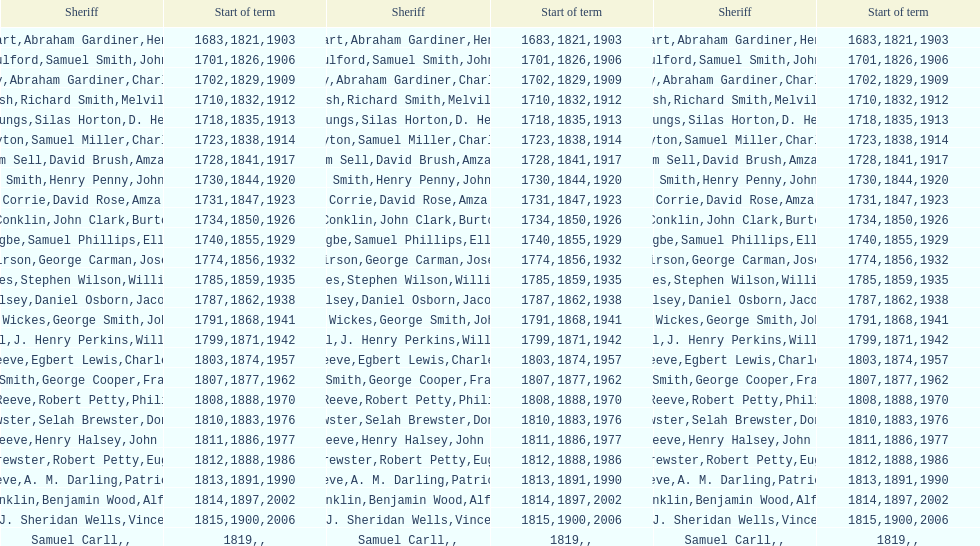Before amza biggs' first term as sheriff in suffolk county, who was the person in charge? Charles O'Dell. 